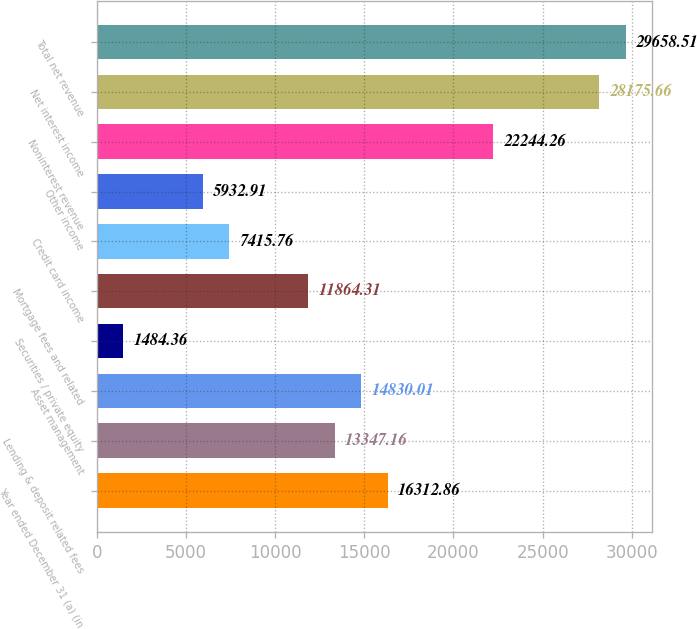<chart> <loc_0><loc_0><loc_500><loc_500><bar_chart><fcel>Year ended December 31 (a) (in<fcel>Lending & deposit related fees<fcel>Asset management<fcel>Securities / private equity<fcel>Mortgage fees and related<fcel>Credit card income<fcel>Other income<fcel>Noninterest revenue<fcel>Net interest income<fcel>Total net revenue<nl><fcel>16312.9<fcel>13347.2<fcel>14830<fcel>1484.36<fcel>11864.3<fcel>7415.76<fcel>5932.91<fcel>22244.3<fcel>28175.7<fcel>29658.5<nl></chart> 